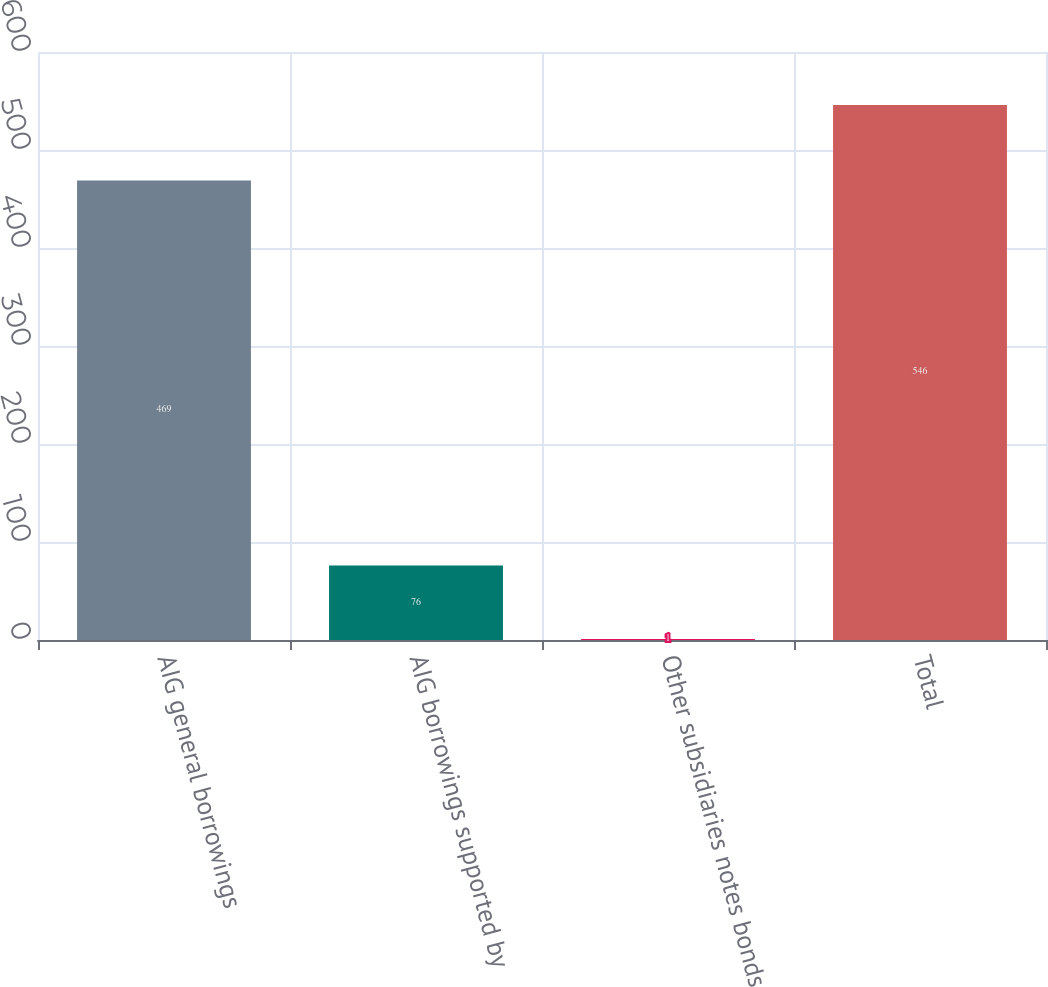Convert chart to OTSL. <chart><loc_0><loc_0><loc_500><loc_500><bar_chart><fcel>AIG general borrowings<fcel>AIG borrowings supported by<fcel>Other subsidiaries notes bonds<fcel>Total<nl><fcel>469<fcel>76<fcel>1<fcel>546<nl></chart> 